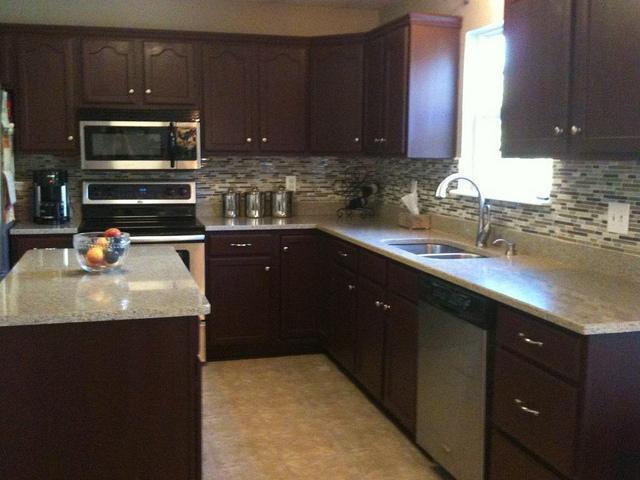How many appliances are there?
Give a very brief answer. 4. 